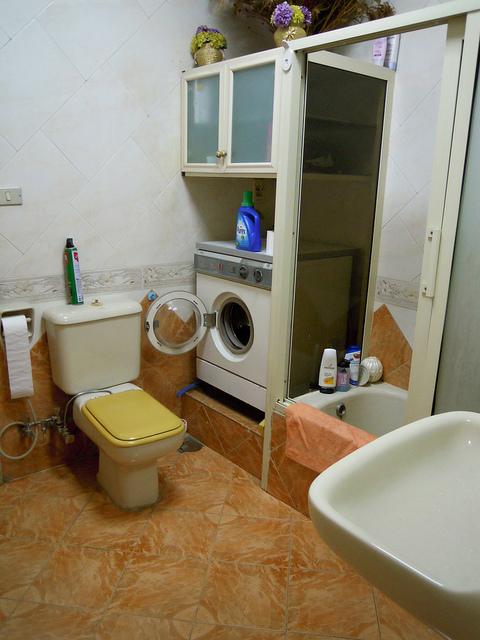Which toilet would you prefer to use?
Answer briefly. Yellow one. Is this bathroom compliant with local building codes?
Write a very short answer. No. What is on the washer?
Be succinct. Detergent. There is a washing detergent?
Keep it brief. Yes. 